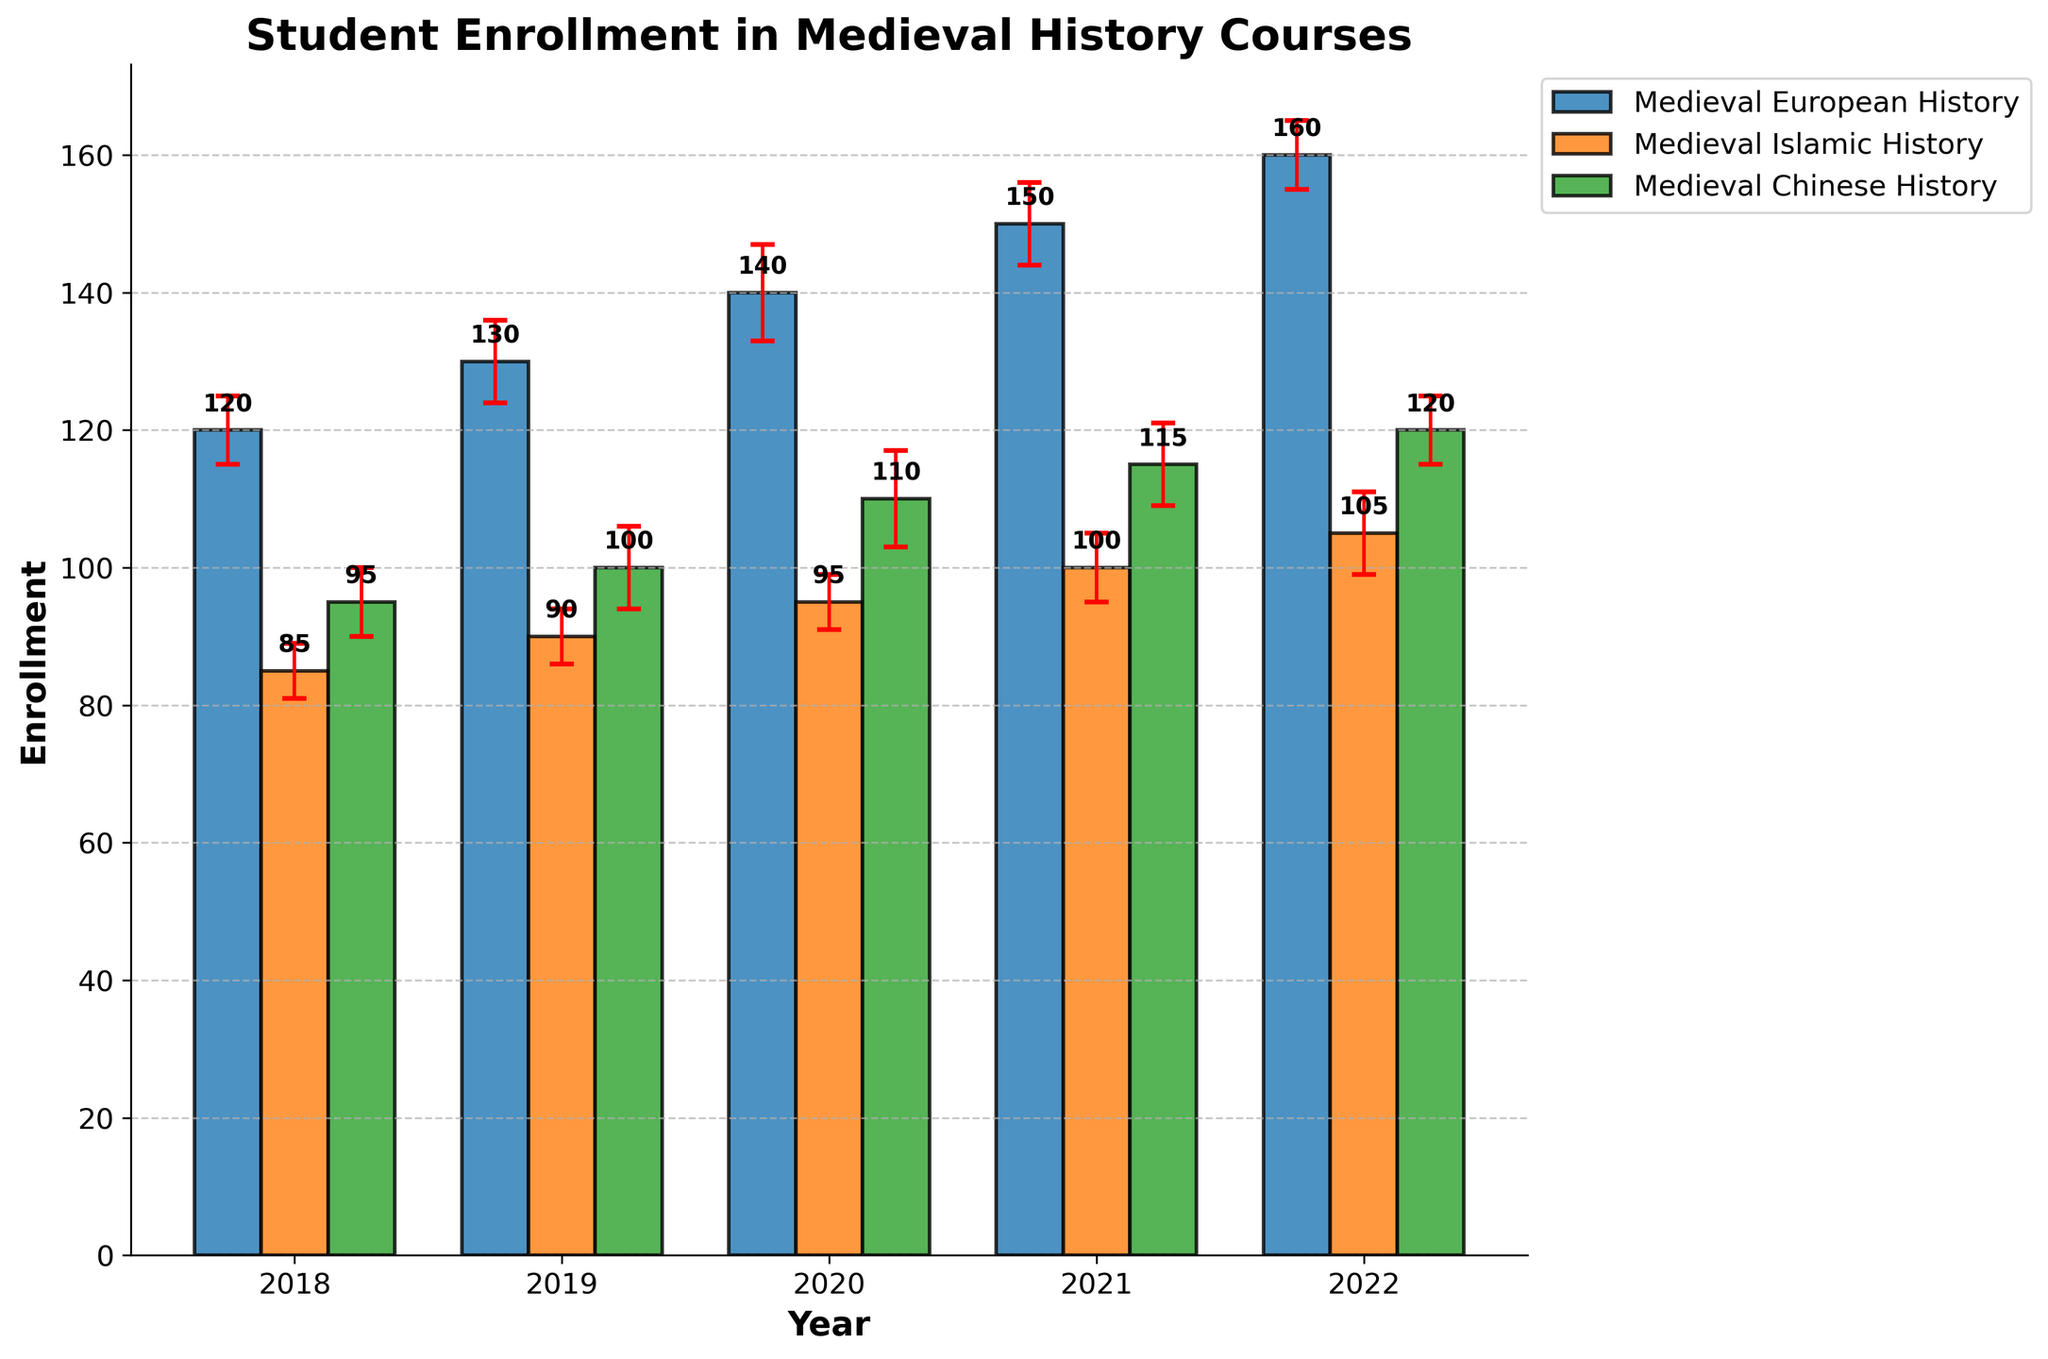What is the title of the chart? The title of the chart is usually displayed at the top of the figure. Here, it reads "Student Enrollment in Medieval History Courses".
Answer: "Student Enrollment in Medieval History Courses" How many years of data does the chart span? To find the span of years, look at the x-axis labels. The labels show data from 2018 to 2022, which covers 5 years.
Answer: 5 years Which course had the highest enrollment in 2022? Check the bars corresponding to 2022 for each course. The highest bar is for "Medieval European History" with 160 enrollments.
Answer: Medieval European History What is the average enrollment in "Medieval Chinese History" across all years? Sum the enrollments for each year: 95 (2018) + 100 (2019) + 110 (2020) + 115 (2021) + 120 (2022) = 540. Then divide by the number of years (5).
Answer: 108 Which course shows the smallest error margin in 2021? Look at the error bars for 2021. "Medieval Chinese History" and "Medieval Islamic History" both have a standard error of 5, but we need to list them both.
Answer: Medieval Chinese History and Medieval Islamic History How does the enrollment of "Medieval Islamic History" in 2018 compare to 2022? Compare the heights of the bars for these years. Enrollment increased from 85 in 2018 to 105 in 2022.
Answer: Increased What is the combined enrollment for all three courses in 2020? Add the enrollment numbers for all courses in 2020: 140 (European) + 95 (Islamic) + 110 (Chinese) = 345.
Answer: 345 Which course had the most consistent enrollment (smallest variation) from 2018 to 2022? Calculate the range for each course: "Medieval European History" (160-120 = 40), "Medieval Islamic History" (105-85 = 20), "Medieval Chinese History" (120-95 = 25). The smallest range indicates the most consistent enrollment.
Answer: Medieval Islamic History What is the difference in enrollment between "Medieval European History" and "Medieval Islamic History" in 2019? Subtract the enrollment of "Medieval Islamic History" from "Medieval European History" for 2019: 130 - 90 = 40.
Answer: 40 